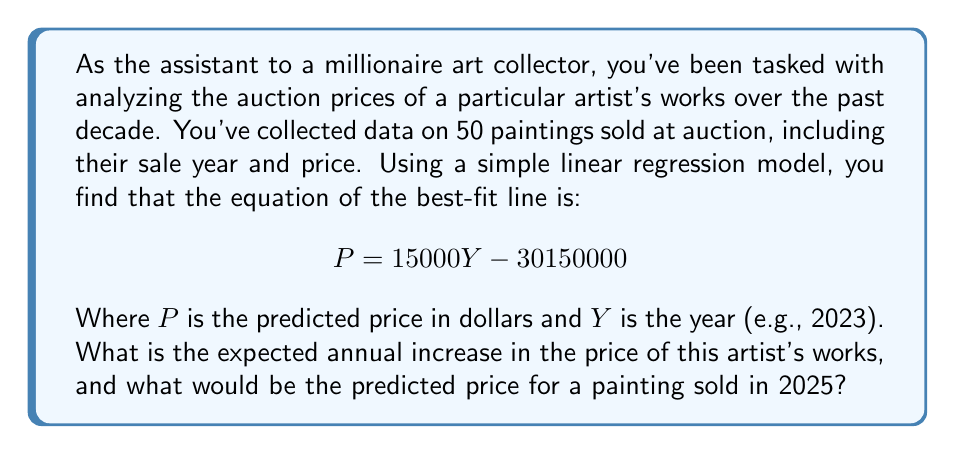What is the answer to this math problem? To solve this problem, we need to interpret the linear regression equation and use it to make predictions.

1. Interpreting the equation:
   The equation $P = 15000Y - 30150000$ is in the form of $y = mx + b$, where:
   - $m = 15000$ is the slope of the line
   - $b = -30150000$ is the y-intercept

2. Expected annual increase:
   The slope of the line represents the expected change in price for each unit change in the year. In this case, the slope is 15000, which means the expected annual increase in price is $15,000 per year.

3. Predicting the price for 2025:
   To find the predicted price for 2025, we simply plug Y = 2025 into the equation:

   $$P = 15000(2025) - 30150000$$
   $$P = 30375000 - 30150000$$
   $$P = 225000$$

Therefore, the predicted price for a painting sold in 2025 would be $225,000.
Answer: The expected annual increase in the price of the artist's works is $15,000, and the predicted price for a painting sold in 2025 would be $225,000. 